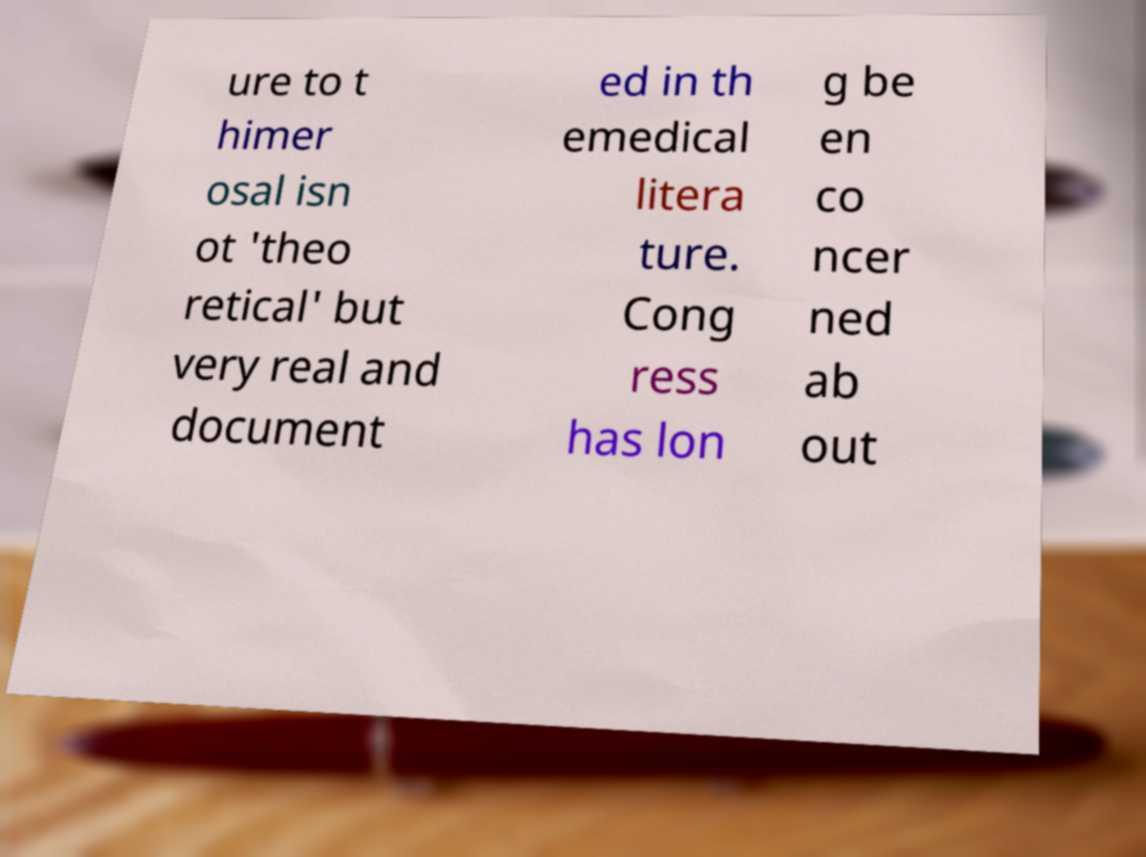Can you read and provide the text displayed in the image?This photo seems to have some interesting text. Can you extract and type it out for me? ure to t himer osal isn ot 'theo retical' but very real and document ed in th emedical litera ture. Cong ress has lon g be en co ncer ned ab out 